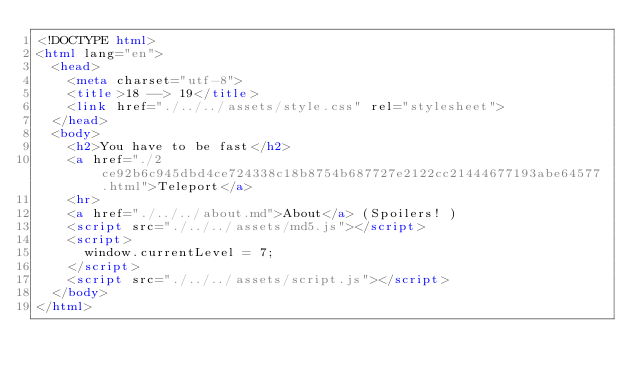Convert code to text. <code><loc_0><loc_0><loc_500><loc_500><_HTML_><!DOCTYPE html>
<html lang="en">
  <head>
    <meta charset="utf-8">
    <title>18 --> 19</title>
    <link href="./../../assets/style.css" rel="stylesheet">
  </head>
  <body>
    <h2>You have to be fast</h2>
    <a href="./2ce92b6c945dbd4ce724338c18b8754b687727e2122cc21444677193abe64577.html">Teleport</a>
    <hr>
    <a href="./../../about.md">About</a> (Spoilers! )
    <script src="./../../assets/md5.js"></script>
    <script>
      window.currentLevel = 7;
    </script>
    <script src="./../../assets/script.js"></script>
  </body>
</html></code> 